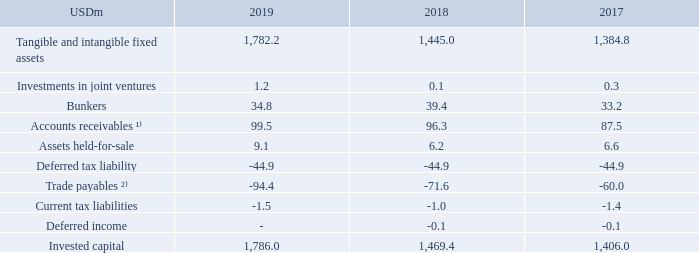Invested capital:
TORM defines invested capital as the sum of intangible assets, tangible fixed assets, investments in joint ventures, bunkers, accounts receivables, assets held-for-sale (when applicable), deferred tax liability, trade payables, current tax liabilities and deferred income. Invested capital measures the net investment used to achieve the Company’s operating profit. The Company believes that invested capital is a relevant measure that Management uses to measure the overall development of the assets and liabilities generating the net profit. Such measure may not be comparable to similarly titled measures of other companies. Invested capital is calculated as follows:
¹⁾ Accounts receivables includes Freight receivables, Other receivables and Prepayments.
²⁾ Trade payables includes Trade payables and Other liabilities.
What does accounts receivables in the table include? Freight receivables, other receivables and prepayments. What does trade payables in the table include? Trade payables and other liabilities. For which years was Invested capital calculated in? 2019, 2018, 2017. In which year was the amount of assets held-for-sale the largest? 9.1>6.6>6.2
Answer: 2019. What was the change in invested capital in 2019 from 2018?
Answer scale should be: million. 1,786.0-1,469.4
Answer: 316.6. What was the percentage change in invested capital in 2019 from 2018?
Answer scale should be: percent. (1,786.0-1,469.4)/1,469.4
Answer: 21.55. 